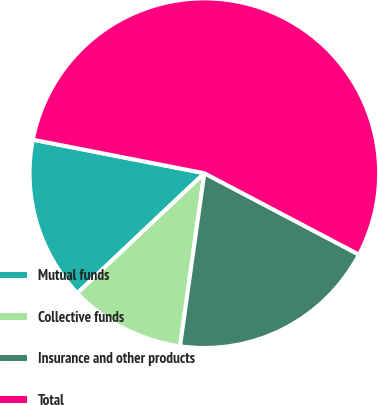Convert chart. <chart><loc_0><loc_0><loc_500><loc_500><pie_chart><fcel>Mutual funds<fcel>Collective funds<fcel>Insurance and other products<fcel>Total<nl><fcel>15.12%<fcel>10.73%<fcel>19.51%<fcel>54.64%<nl></chart> 